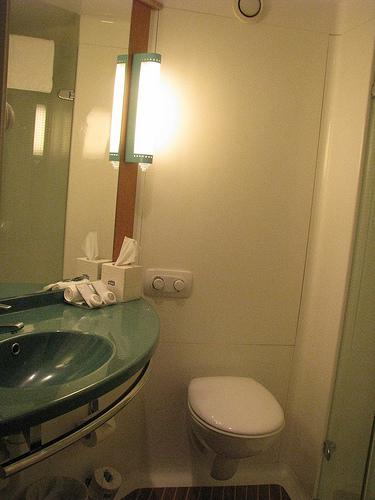Question: what is on the sink?
Choices:
A. A box of tissues.
B. Soap.
C. Brushes.
D. Dishes.
Answer with the letter. Answer: A Question: why can't we see in the toilet?
Choices:
A. It is censored.
B. Toilet lid is closed.
C. Someone is sitting on it.
D. The angle.
Answer with the letter. Answer: B Question: where was this photo taken?
Choices:
A. Bedroom.
B. Kitchen.
C. A bathroom.
D. Dining room.
Answer with the letter. Answer: C Question: how many rolls of toilet paper are visible?
Choices:
A. Three.
B. One.
C. Two.
D. Four.
Answer with the letter. Answer: C 